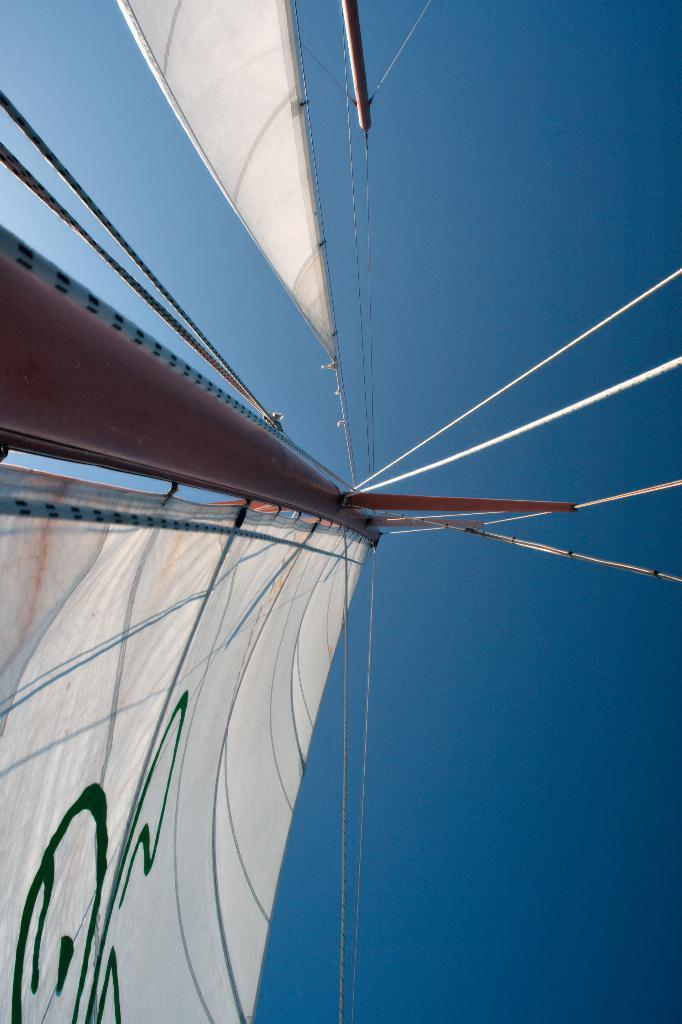What is hanging from the pole in the image? There are clothes tied to a pole in the image. What is used to hang the clothes on the pole? There are ropes in the image. What structures are present in the image? There are poles in the image. What can be seen in the background of the image? The sky is visible in the image. Can you see a rabbit hopping near the pole in the image? There is no rabbit present in the image. What type of beetle can be seen crawling on the clothes in the image? There are no beetles present in the image. 